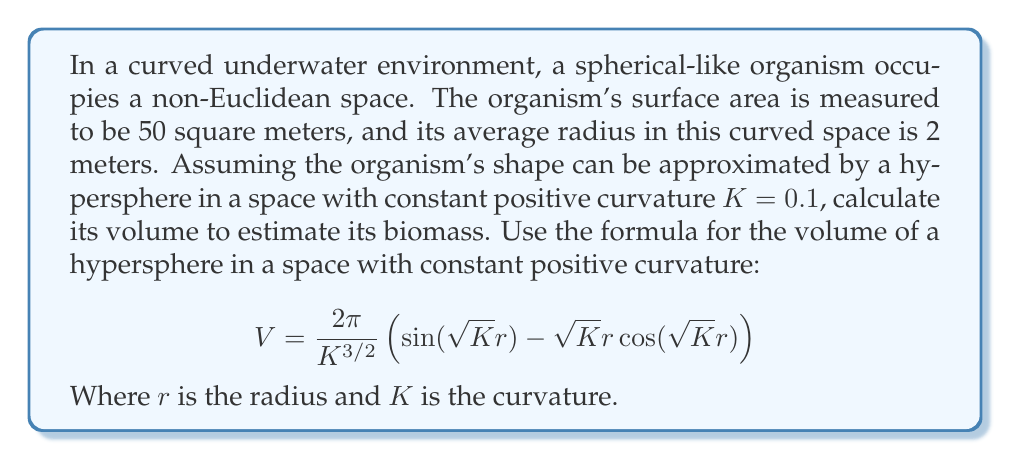What is the answer to this math problem? To solve this problem, we'll follow these steps:

1) First, let's identify the given values:
   $K = 0.1$ (curvature)
   $r = 2$ meters (average radius)

2) Now, let's substitute these values into the formula:

   $$V = \frac{2\pi}{0.1^{3/2}} \left(\sin(\sqrt{0.1} \cdot 2) - \sqrt{0.1} \cdot 2 \cos(\sqrt{0.1} \cdot 2)\right)$$

3) Let's simplify step by step:
   
   a) $\sqrt{0.1} = 0.3162$
   b) $\sqrt{0.1} \cdot 2 = 0.6324$

4) Substituting these values:

   $$V = \frac{2\pi}{0.1^{3/2}} \left(\sin(0.6324) - 0.6324 \cos(0.6324)\right)$$

5) Calculate the trigonometric functions:
   
   $\sin(0.6324) = 0.5902$
   $\cos(0.6324) = 0.8072$

6) Substituting again:

   $$V = \frac{2\pi}{0.1^{3/2}} (0.5902 - 0.6324 \cdot 0.8072)$$

7) Simplify the bracket:
   
   $$V = \frac{2\pi}{0.1^{3/2}} (0.5902 - 0.5105) = \frac{2\pi}{0.1^{3/2}} (0.0797)$$

8) Calculate $0.1^{3/2} = 0.0316$

9) Final calculation:

   $$V = \frac{2\pi}{0.0316} \cdot 0.0797 = 15.8489$$

Therefore, the volume of the organism in this non-Euclidean space is approximately 15.8489 cubic meters.
Answer: $15.8489 \text{ m}^3$ 